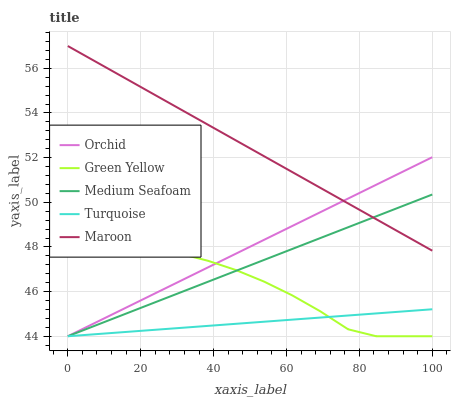Does Turquoise have the minimum area under the curve?
Answer yes or no. Yes. Does Maroon have the maximum area under the curve?
Answer yes or no. Yes. Does Green Yellow have the minimum area under the curve?
Answer yes or no. No. Does Green Yellow have the maximum area under the curve?
Answer yes or no. No. Is Turquoise the smoothest?
Answer yes or no. Yes. Is Green Yellow the roughest?
Answer yes or no. Yes. Is Medium Seafoam the smoothest?
Answer yes or no. No. Is Medium Seafoam the roughest?
Answer yes or no. No. Does Turquoise have the lowest value?
Answer yes or no. Yes. Does Maroon have the lowest value?
Answer yes or no. No. Does Maroon have the highest value?
Answer yes or no. Yes. Does Green Yellow have the highest value?
Answer yes or no. No. Is Turquoise less than Maroon?
Answer yes or no. Yes. Is Maroon greater than Turquoise?
Answer yes or no. Yes. Does Medium Seafoam intersect Turquoise?
Answer yes or no. Yes. Is Medium Seafoam less than Turquoise?
Answer yes or no. No. Is Medium Seafoam greater than Turquoise?
Answer yes or no. No. Does Turquoise intersect Maroon?
Answer yes or no. No. 